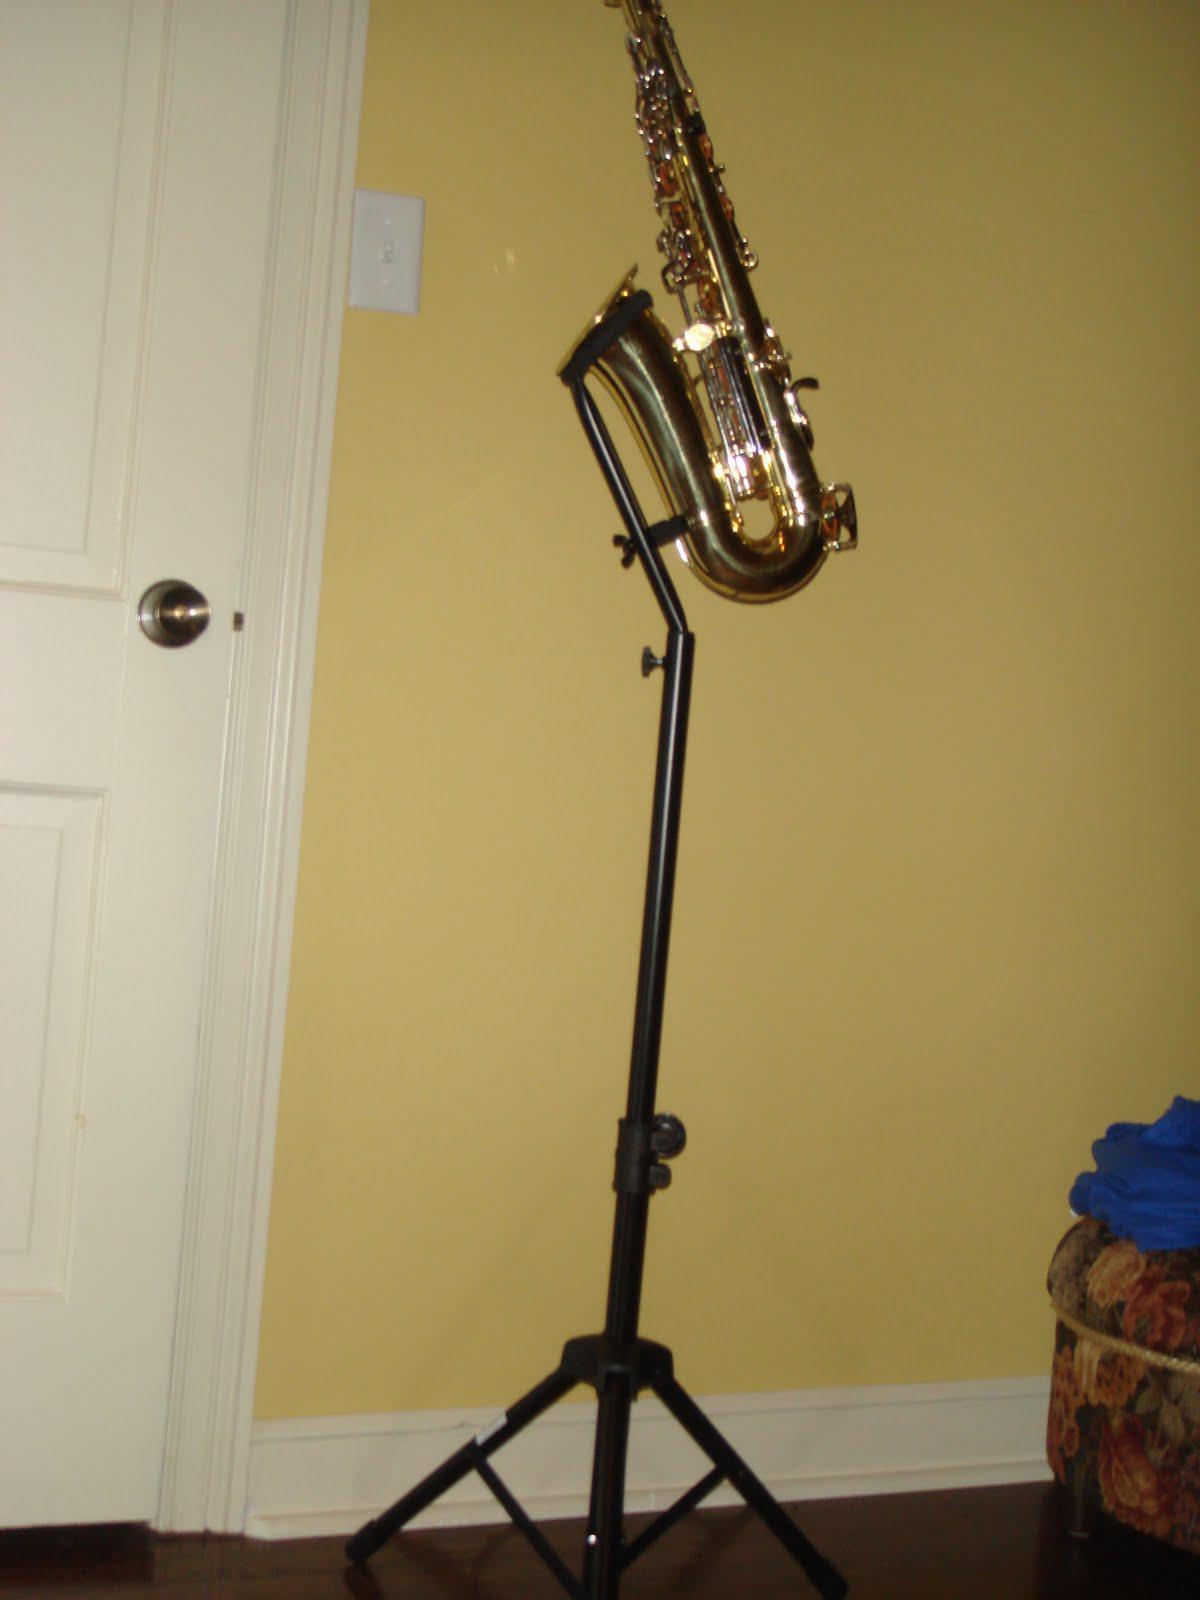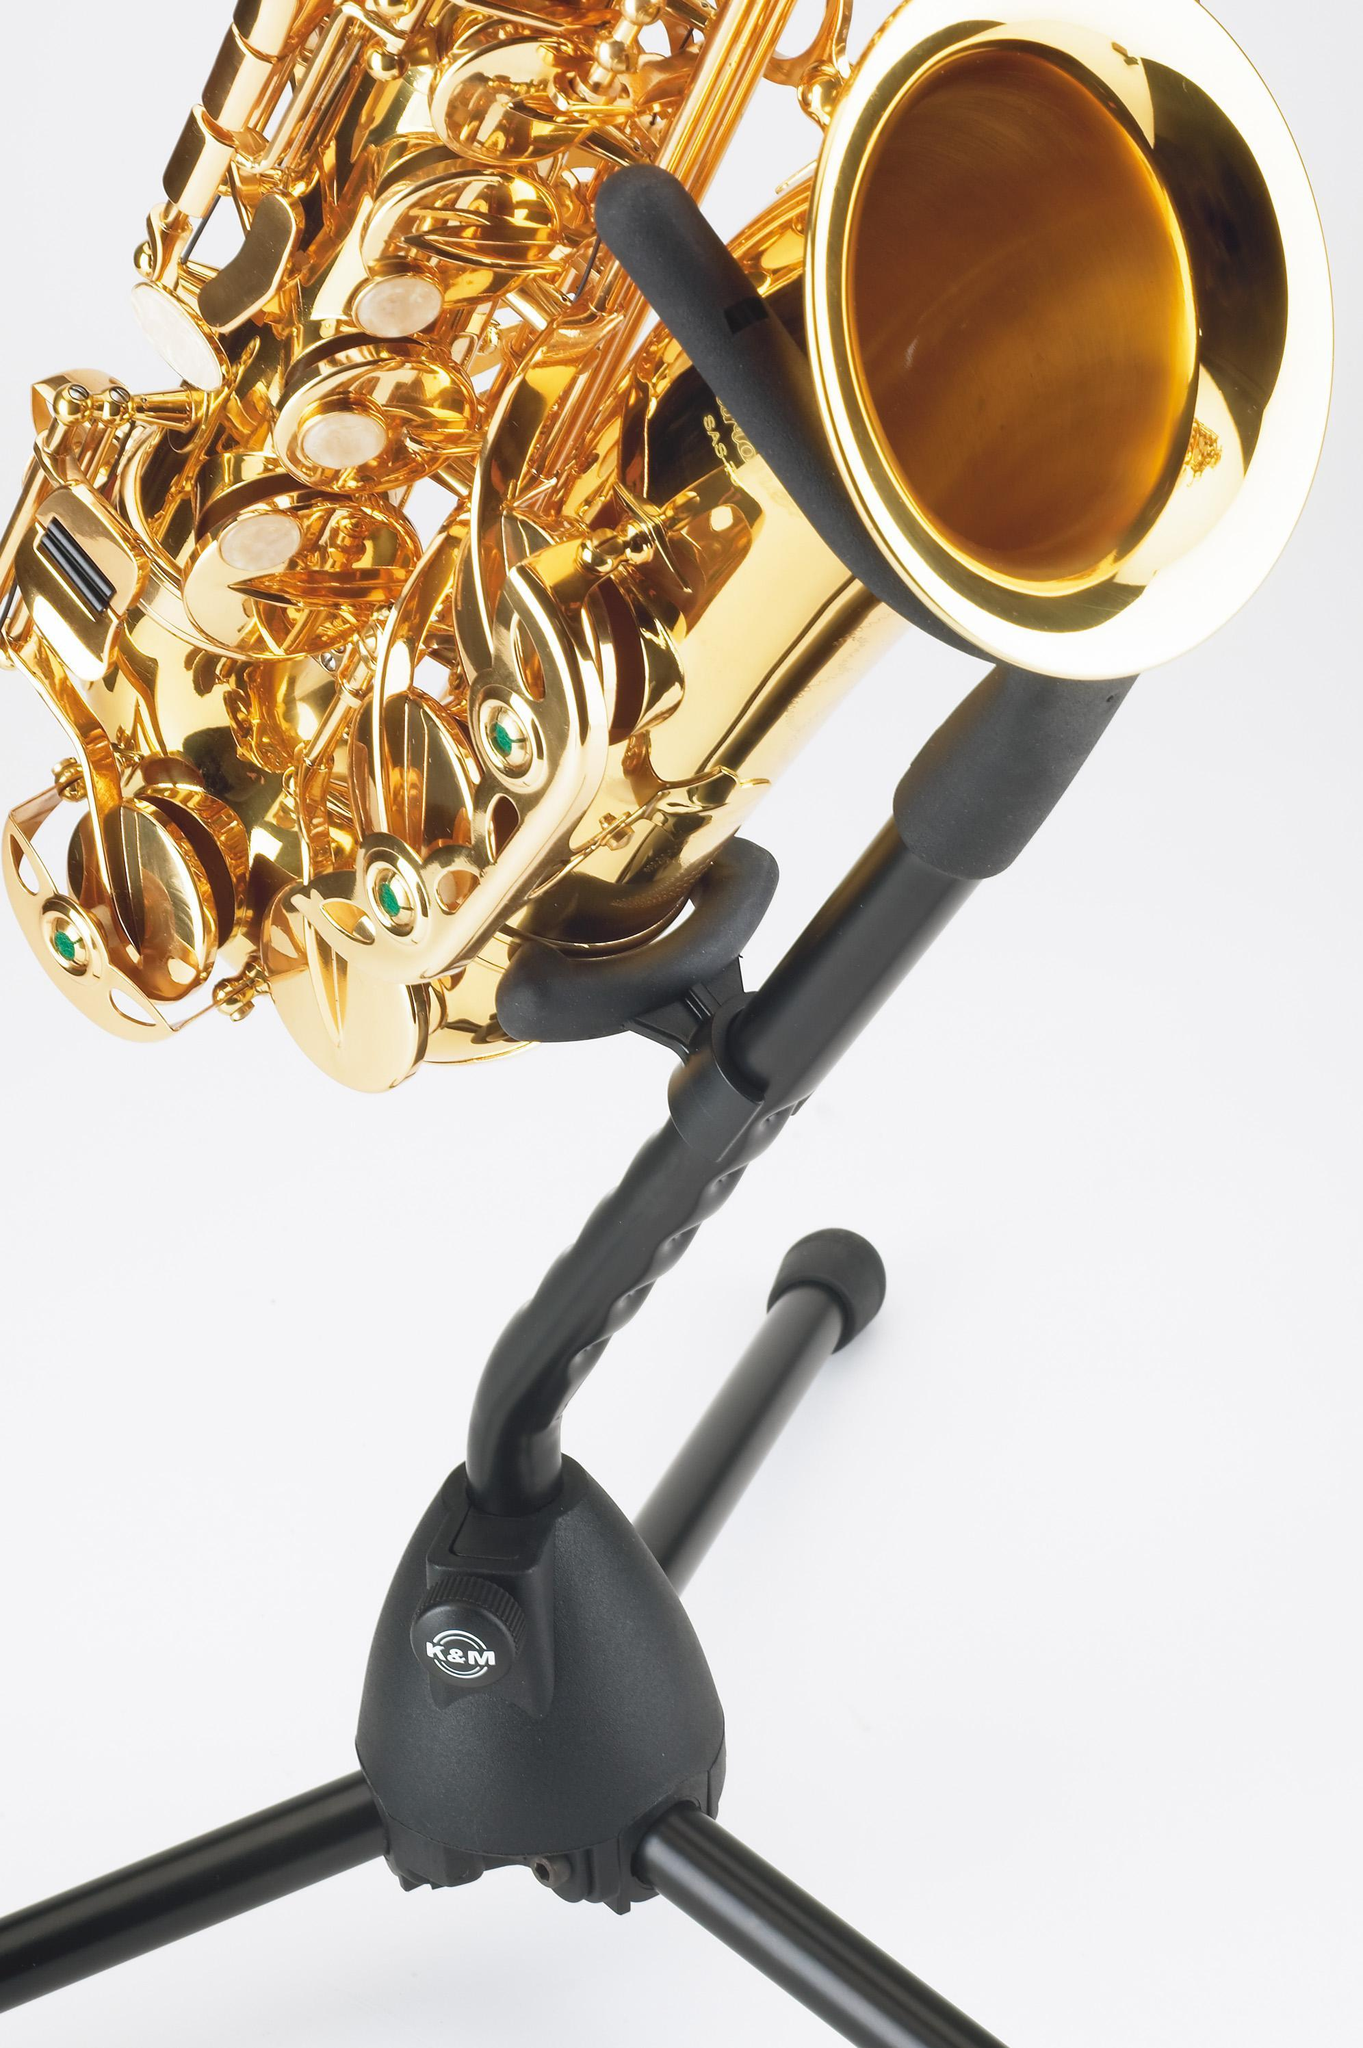The first image is the image on the left, the second image is the image on the right. Given the left and right images, does the statement "The left and right image contains the same number of saxophones being held by their stand alone." hold true? Answer yes or no. Yes. The first image is the image on the left, the second image is the image on the right. Considering the images on both sides, is "The trombone is facing to the right in the right image." valid? Answer yes or no. Yes. 